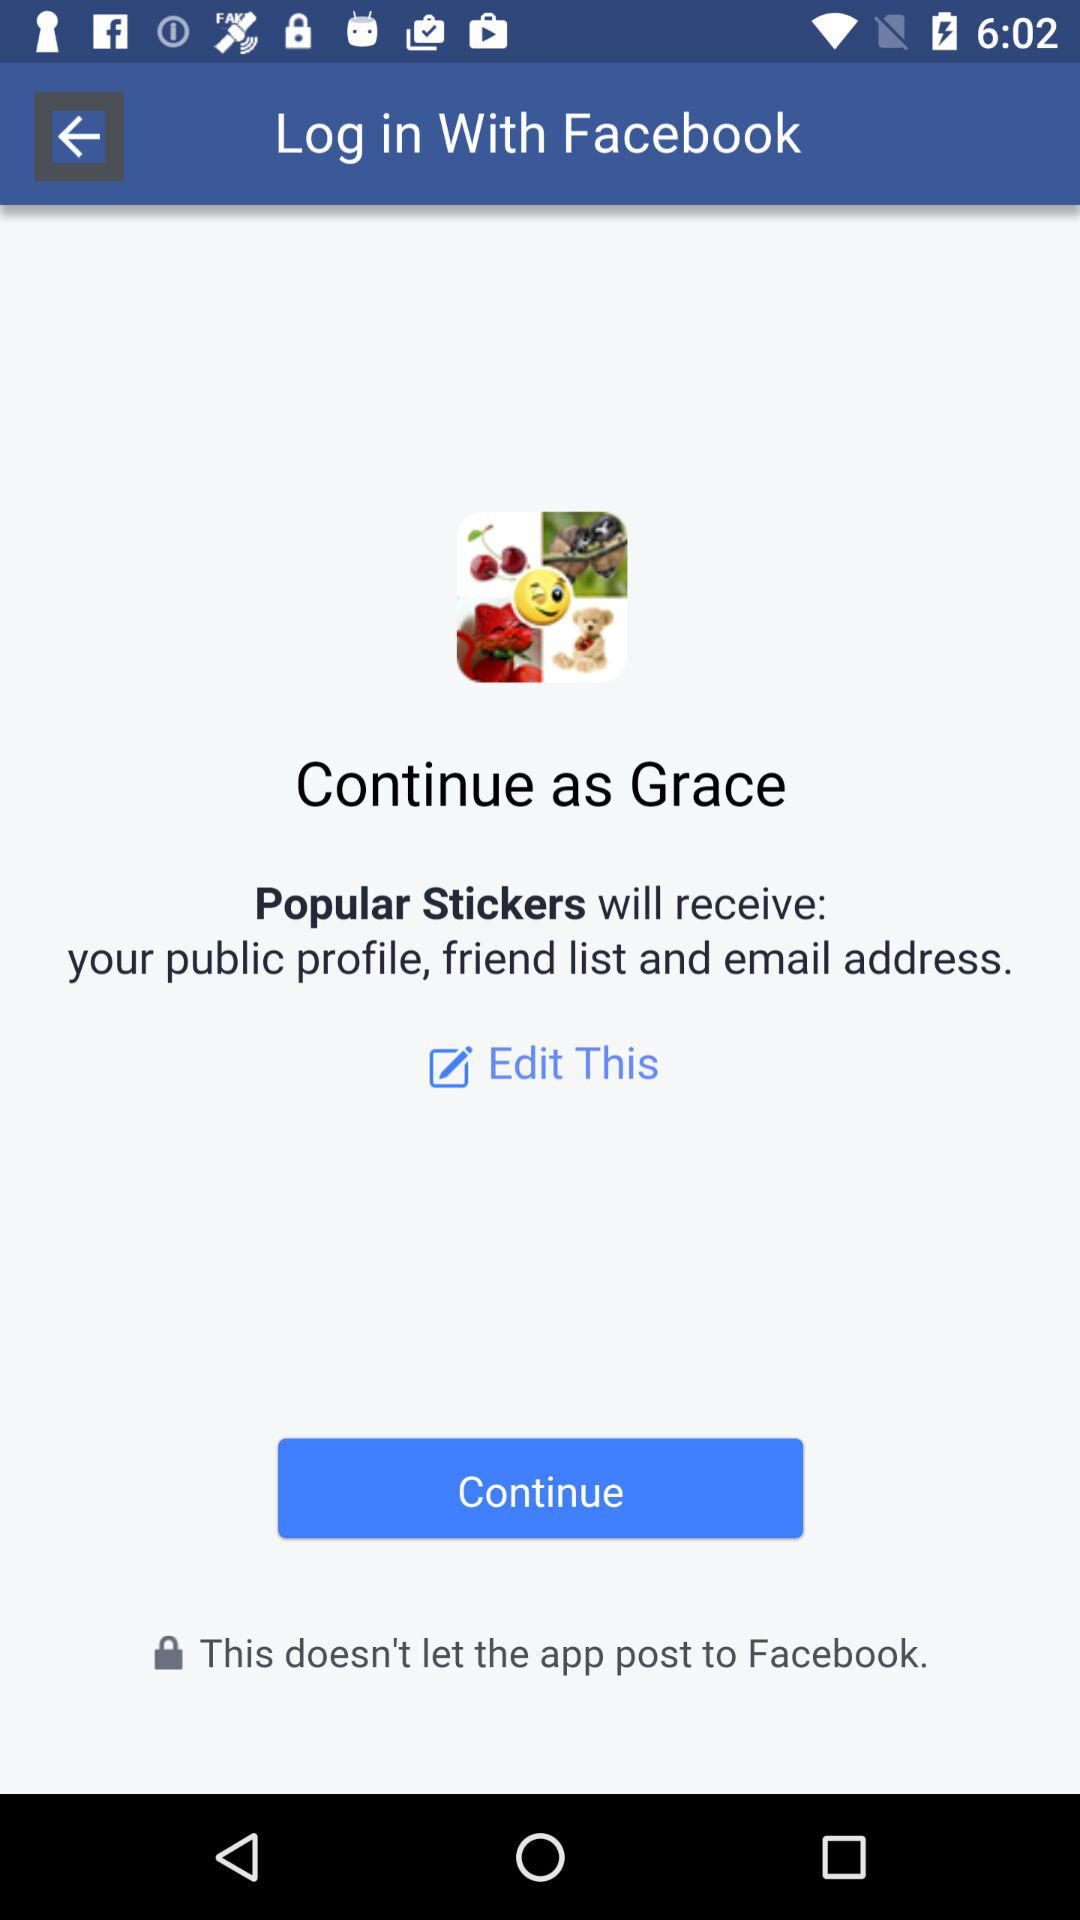Who will receive the public profile,friend list and email address? The public profile,friend list and email address will be received by "Popular Stickers ". 